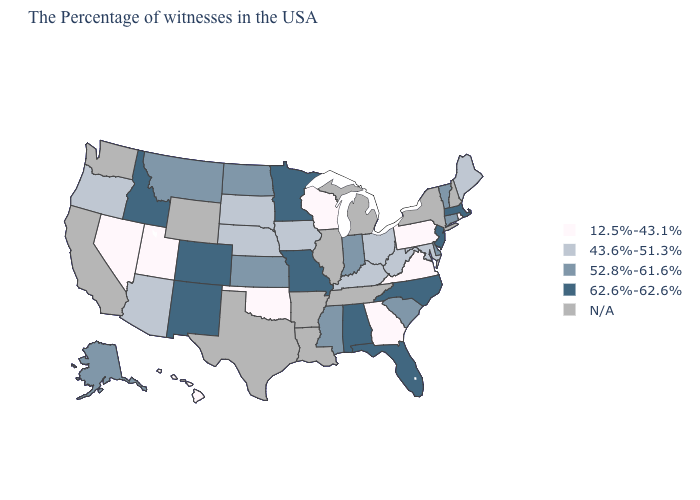What is the lowest value in the South?
Write a very short answer. 12.5%-43.1%. Name the states that have a value in the range 12.5%-43.1%?
Be succinct. Rhode Island, Pennsylvania, Virginia, Georgia, Wisconsin, Oklahoma, Utah, Nevada, Hawaii. What is the value of Rhode Island?
Keep it brief. 12.5%-43.1%. Does Idaho have the highest value in the USA?
Keep it brief. Yes. Name the states that have a value in the range N/A?
Answer briefly. New Hampshire, New York, Michigan, Tennessee, Illinois, Louisiana, Arkansas, Texas, Wyoming, California, Washington. What is the lowest value in the MidWest?
Quick response, please. 12.5%-43.1%. Name the states that have a value in the range 52.8%-61.6%?
Be succinct. Vermont, Connecticut, Delaware, South Carolina, Indiana, Mississippi, Kansas, North Dakota, Montana, Alaska. Does Rhode Island have the lowest value in the Northeast?
Be succinct. Yes. Among the states that border Connecticut , which have the highest value?
Concise answer only. Massachusetts. Name the states that have a value in the range 12.5%-43.1%?
Concise answer only. Rhode Island, Pennsylvania, Virginia, Georgia, Wisconsin, Oklahoma, Utah, Nevada, Hawaii. What is the value of Washington?
Answer briefly. N/A. What is the value of Michigan?
Keep it brief. N/A. Name the states that have a value in the range 43.6%-51.3%?
Write a very short answer. Maine, Maryland, West Virginia, Ohio, Kentucky, Iowa, Nebraska, South Dakota, Arizona, Oregon. What is the lowest value in the MidWest?
Answer briefly. 12.5%-43.1%. Name the states that have a value in the range 62.6%-62.6%?
Keep it brief. Massachusetts, New Jersey, North Carolina, Florida, Alabama, Missouri, Minnesota, Colorado, New Mexico, Idaho. 